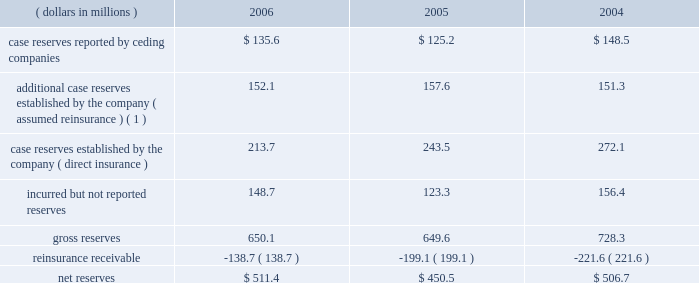Development of prior year incurred losses was $ 135.6 million unfavorable in 2006 , $ 26.4 million favorable in 2005 and $ 249.4 million unfavorable in 2004 .
Such losses were the result of the reserve development noted above , as well as inher- ent uncertainty in establishing loss and lae reserves .
Reserves for asbestos and environmental losses and loss adjustment expenses as of year end 2006 , 7.4% ( 7.4 % ) of reserves reflect an estimate for the company 2019s ultimate liability for a&e claims for which ulti- mate value cannot be estimated using traditional reserving techniques .
The company 2019s a&e liabilities stem from mt .
Mckinley 2019s direct insurance business and everest re 2019s assumed reinsurance business .
There are significant uncertainties in estimating the amount of the company 2019s potential losses from a&e claims .
See item 7 , 201cmanagement 2019s discussion and analysis of financial condition and results of operations 2014asbestos and environmental exposures 201d and note 3 of notes to consolidated financial statements .
Mt .
Mckinley 2019s book of direct a&e exposed insurance is relatively small and homogenous .
It also arises from a limited period , effective 1978 to 1984 .
The book is based principally on excess liability policies , thereby limiting exposure analysis to a lim- ited number of policies and forms .
As a result of this focused structure , the company believes that it is able to comprehen- sively analyze its exposures , allowing it to identify , analyze and actively monitor those claims which have unusual exposure , including policies in which it may be exposed to pay expenses in addition to policy limits or non-products asbestos claims .
The company endeavors to be actively engaged with every insured account posing significant potential asbestos exposure to mt .
Mckinley .
Such engagement can take the form of pursuing a final settlement , negotiation , litigation , or the monitoring of claim activity under settlement in place ( 201csip 201d ) agreements .
Sip agreements generally condition an insurer 2019s payment upon the actual claim experience of the insured and may have annual payment caps or other measures to control the insurer 2019s payments .
The company 2019s mt .
Mckinley operation is currently managing eight sip agreements , three of which were executed prior to the acquisition of mt .
Mckinley in 2000 .
The company 2019s preference with respect to coverage settlements is to exe- cute settlements that call for a fixed schedule of payments , because such settlements eliminate future uncertainty .
The company has significantly enhanced its classification of insureds by exposure characteristics over time , as well as its analysis by insured for those it considers to be more exposed or active .
Those insureds identified as relatively less exposed or active are subject to less rigorous , but still active management , with an emphasis on monitoring those characteristics , which may indicate an increasing exposure or levels of activity .
The company continually focuses on further enhancement of the detailed estimation processes used to evaluate potential exposure of policyholders , including those that may not have reported significant a&e losses .
Everest re 2019s book of assumed reinsurance is relatively concentrated within a modest number of a&e exposed relationships .
It also arises from a limited period , effectively 1977 to 1984 .
Because the book of business is relatively concentrated and the company has been managing the a&e exposures for many years , its claim staff is familiar with the ceding companies that have generated most of these liabilities in the past and which are therefore most likely to generate future liabilities .
The company 2019s claim staff has developed familiarity both with the nature of the business written by its ceding companies and the claims handling and reserving practices of those companies .
This level of familiarity enhances the quality of the company 2019s analysis of its exposure through those companies .
As a result , the company believes that it can identify those claims on which it has unusual exposure , such as non-products asbestos claims , for concentrated attention .
However , in setting reserves for its reinsurance liabilities , the company relies on claims data supplied , both formally and informally by its ceding companies and brokers .
This furnished information is not always timely or accurate and can impact the accuracy and timeli- ness of the company 2019s ultimate loss projections .
The table summarizes the composition of the company 2019s total reserves for a&e losses , gross and net of reinsurance , for the years ended december 31: .
( 1 ) additional reserves are case specific reserves determined by the company to be needed over and above those reported by the ceding company .
81790fin_a 4/13/07 11:08 am page 15 .
What is the average gross reserves from 2004 to 2006 in millions? 
Computations: ((((650.1 + 649.6) + 728.3) + 3) / 2)
Answer: 1015.5. Development of prior year incurred losses was $ 135.6 million unfavorable in 2006 , $ 26.4 million favorable in 2005 and $ 249.4 million unfavorable in 2004 .
Such losses were the result of the reserve development noted above , as well as inher- ent uncertainty in establishing loss and lae reserves .
Reserves for asbestos and environmental losses and loss adjustment expenses as of year end 2006 , 7.4% ( 7.4 % ) of reserves reflect an estimate for the company 2019s ultimate liability for a&e claims for which ulti- mate value cannot be estimated using traditional reserving techniques .
The company 2019s a&e liabilities stem from mt .
Mckinley 2019s direct insurance business and everest re 2019s assumed reinsurance business .
There are significant uncertainties in estimating the amount of the company 2019s potential losses from a&e claims .
See item 7 , 201cmanagement 2019s discussion and analysis of financial condition and results of operations 2014asbestos and environmental exposures 201d and note 3 of notes to consolidated financial statements .
Mt .
Mckinley 2019s book of direct a&e exposed insurance is relatively small and homogenous .
It also arises from a limited period , effective 1978 to 1984 .
The book is based principally on excess liability policies , thereby limiting exposure analysis to a lim- ited number of policies and forms .
As a result of this focused structure , the company believes that it is able to comprehen- sively analyze its exposures , allowing it to identify , analyze and actively monitor those claims which have unusual exposure , including policies in which it may be exposed to pay expenses in addition to policy limits or non-products asbestos claims .
The company endeavors to be actively engaged with every insured account posing significant potential asbestos exposure to mt .
Mckinley .
Such engagement can take the form of pursuing a final settlement , negotiation , litigation , or the monitoring of claim activity under settlement in place ( 201csip 201d ) agreements .
Sip agreements generally condition an insurer 2019s payment upon the actual claim experience of the insured and may have annual payment caps or other measures to control the insurer 2019s payments .
The company 2019s mt .
Mckinley operation is currently managing eight sip agreements , three of which were executed prior to the acquisition of mt .
Mckinley in 2000 .
The company 2019s preference with respect to coverage settlements is to exe- cute settlements that call for a fixed schedule of payments , because such settlements eliminate future uncertainty .
The company has significantly enhanced its classification of insureds by exposure characteristics over time , as well as its analysis by insured for those it considers to be more exposed or active .
Those insureds identified as relatively less exposed or active are subject to less rigorous , but still active management , with an emphasis on monitoring those characteristics , which may indicate an increasing exposure or levels of activity .
The company continually focuses on further enhancement of the detailed estimation processes used to evaluate potential exposure of policyholders , including those that may not have reported significant a&e losses .
Everest re 2019s book of assumed reinsurance is relatively concentrated within a modest number of a&e exposed relationships .
It also arises from a limited period , effectively 1977 to 1984 .
Because the book of business is relatively concentrated and the company has been managing the a&e exposures for many years , its claim staff is familiar with the ceding companies that have generated most of these liabilities in the past and which are therefore most likely to generate future liabilities .
The company 2019s claim staff has developed familiarity both with the nature of the business written by its ceding companies and the claims handling and reserving practices of those companies .
This level of familiarity enhances the quality of the company 2019s analysis of its exposure through those companies .
As a result , the company believes that it can identify those claims on which it has unusual exposure , such as non-products asbestos claims , for concentrated attention .
However , in setting reserves for its reinsurance liabilities , the company relies on claims data supplied , both formally and informally by its ceding companies and brokers .
This furnished information is not always timely or accurate and can impact the accuracy and timeli- ness of the company 2019s ultimate loss projections .
The table summarizes the composition of the company 2019s total reserves for a&e losses , gross and net of reinsurance , for the years ended december 31: .
( 1 ) additional reserves are case specific reserves determined by the company to be needed over and above those reported by the ceding company .
81790fin_a 4/13/07 11:08 am page 15 .
What is the growth rate in net reserves in 2006? 
Computations: ((511.4 - 450.5) / 450.5)
Answer: 0.13518. Development of prior year incurred losses was $ 135.6 million unfavorable in 2006 , $ 26.4 million favorable in 2005 and $ 249.4 million unfavorable in 2004 .
Such losses were the result of the reserve development noted above , as well as inher- ent uncertainty in establishing loss and lae reserves .
Reserves for asbestos and environmental losses and loss adjustment expenses as of year end 2006 , 7.4% ( 7.4 % ) of reserves reflect an estimate for the company 2019s ultimate liability for a&e claims for which ulti- mate value cannot be estimated using traditional reserving techniques .
The company 2019s a&e liabilities stem from mt .
Mckinley 2019s direct insurance business and everest re 2019s assumed reinsurance business .
There are significant uncertainties in estimating the amount of the company 2019s potential losses from a&e claims .
See item 7 , 201cmanagement 2019s discussion and analysis of financial condition and results of operations 2014asbestos and environmental exposures 201d and note 3 of notes to consolidated financial statements .
Mt .
Mckinley 2019s book of direct a&e exposed insurance is relatively small and homogenous .
It also arises from a limited period , effective 1978 to 1984 .
The book is based principally on excess liability policies , thereby limiting exposure analysis to a lim- ited number of policies and forms .
As a result of this focused structure , the company believes that it is able to comprehen- sively analyze its exposures , allowing it to identify , analyze and actively monitor those claims which have unusual exposure , including policies in which it may be exposed to pay expenses in addition to policy limits or non-products asbestos claims .
The company endeavors to be actively engaged with every insured account posing significant potential asbestos exposure to mt .
Mckinley .
Such engagement can take the form of pursuing a final settlement , negotiation , litigation , or the monitoring of claim activity under settlement in place ( 201csip 201d ) agreements .
Sip agreements generally condition an insurer 2019s payment upon the actual claim experience of the insured and may have annual payment caps or other measures to control the insurer 2019s payments .
The company 2019s mt .
Mckinley operation is currently managing eight sip agreements , three of which were executed prior to the acquisition of mt .
Mckinley in 2000 .
The company 2019s preference with respect to coverage settlements is to exe- cute settlements that call for a fixed schedule of payments , because such settlements eliminate future uncertainty .
The company has significantly enhanced its classification of insureds by exposure characteristics over time , as well as its analysis by insured for those it considers to be more exposed or active .
Those insureds identified as relatively less exposed or active are subject to less rigorous , but still active management , with an emphasis on monitoring those characteristics , which may indicate an increasing exposure or levels of activity .
The company continually focuses on further enhancement of the detailed estimation processes used to evaluate potential exposure of policyholders , including those that may not have reported significant a&e losses .
Everest re 2019s book of assumed reinsurance is relatively concentrated within a modest number of a&e exposed relationships .
It also arises from a limited period , effectively 1977 to 1984 .
Because the book of business is relatively concentrated and the company has been managing the a&e exposures for many years , its claim staff is familiar with the ceding companies that have generated most of these liabilities in the past and which are therefore most likely to generate future liabilities .
The company 2019s claim staff has developed familiarity both with the nature of the business written by its ceding companies and the claims handling and reserving practices of those companies .
This level of familiarity enhances the quality of the company 2019s analysis of its exposure through those companies .
As a result , the company believes that it can identify those claims on which it has unusual exposure , such as non-products asbestos claims , for concentrated attention .
However , in setting reserves for its reinsurance liabilities , the company relies on claims data supplied , both formally and informally by its ceding companies and brokers .
This furnished information is not always timely or accurate and can impact the accuracy and timeli- ness of the company 2019s ultimate loss projections .
The table summarizes the composition of the company 2019s total reserves for a&e losses , gross and net of reinsurance , for the years ended december 31: .
( 1 ) additional reserves are case specific reserves determined by the company to be needed over and above those reported by the ceding company .
81790fin_a 4/13/07 11:08 am page 15 .
What is the growth rate in net reserves in 2005? 
Computations: ((450.5 - 506.7) / 506.7)
Answer: -0.11091. 